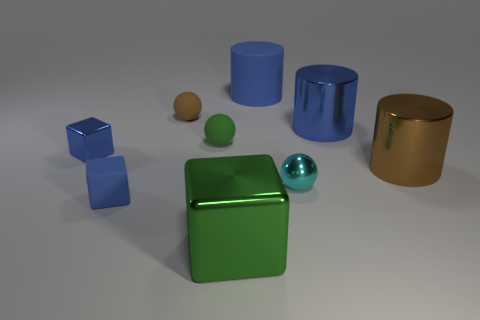Subtract all big blue matte cylinders. How many cylinders are left? 2 Subtract all cyan cubes. How many blue cylinders are left? 2 Subtract all cylinders. How many objects are left? 6 Add 1 brown matte spheres. How many objects exist? 10 Subtract all blue cylinders. How many cylinders are left? 1 Subtract 1 cylinders. How many cylinders are left? 2 Add 4 small blue rubber cubes. How many small blue rubber cubes are left? 5 Add 9 tiny blue metal objects. How many tiny blue metal objects exist? 10 Subtract 0 brown cubes. How many objects are left? 9 Subtract all cyan blocks. Subtract all cyan cylinders. How many blocks are left? 3 